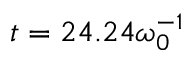Convert formula to latex. <formula><loc_0><loc_0><loc_500><loc_500>t = 2 4 . 2 4 \omega _ { 0 } ^ { - 1 }</formula> 